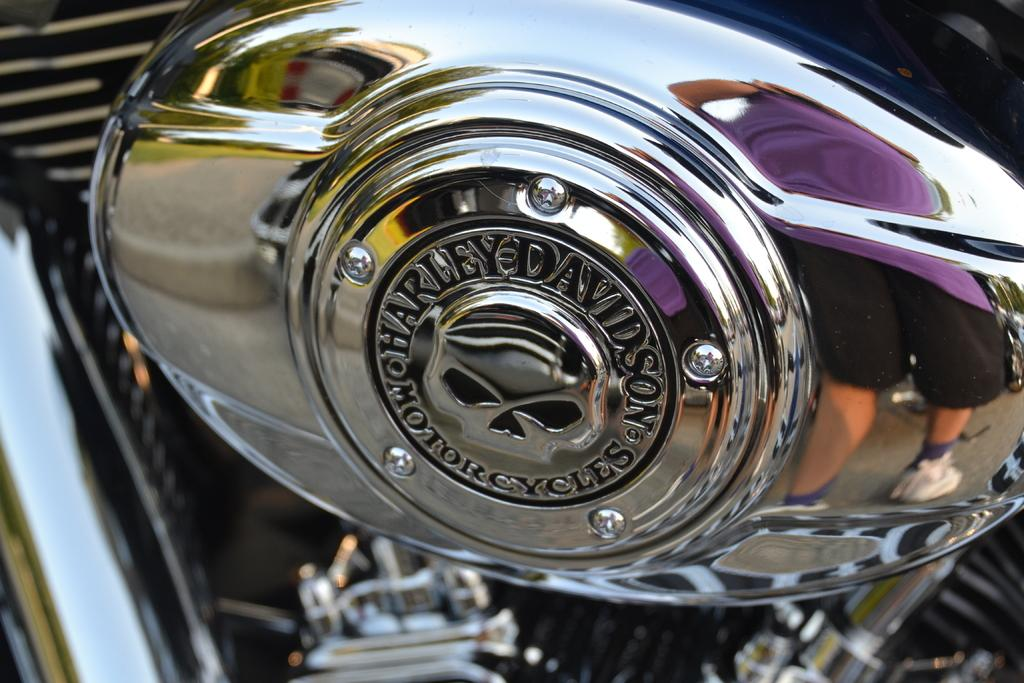What type of vehicle is featured in the image? The image features a metal tank of a motorbike. Can you describe the main component of the motorbike that is visible in the image? The metal tank is the main component of the motorbike that is visible in the image. What type of seat can be seen on the motorbike in the image? There is no seat visible in the image, as only the metal tank of the motorbike is shown. 